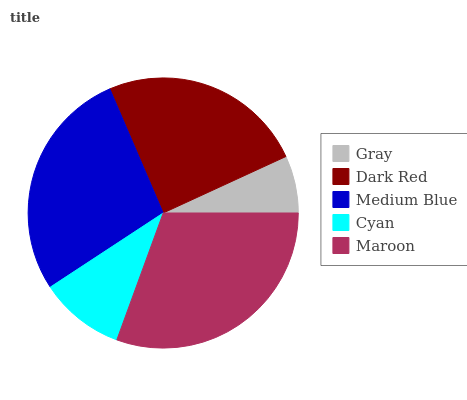Is Gray the minimum?
Answer yes or no. Yes. Is Maroon the maximum?
Answer yes or no. Yes. Is Dark Red the minimum?
Answer yes or no. No. Is Dark Red the maximum?
Answer yes or no. No. Is Dark Red greater than Gray?
Answer yes or no. Yes. Is Gray less than Dark Red?
Answer yes or no. Yes. Is Gray greater than Dark Red?
Answer yes or no. No. Is Dark Red less than Gray?
Answer yes or no. No. Is Dark Red the high median?
Answer yes or no. Yes. Is Dark Red the low median?
Answer yes or no. Yes. Is Cyan the high median?
Answer yes or no. No. Is Cyan the low median?
Answer yes or no. No. 